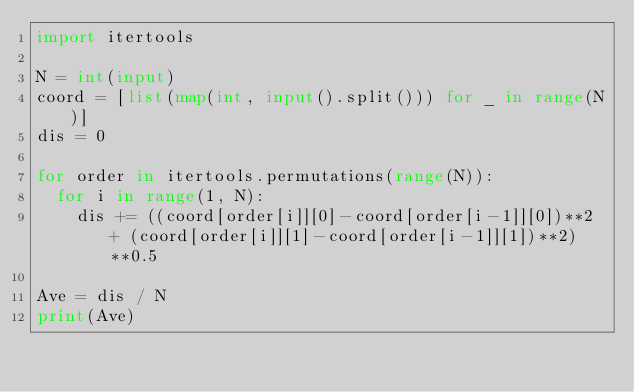Convert code to text. <code><loc_0><loc_0><loc_500><loc_500><_Python_>import itertools
 
N = int(input)
coord = [list(map(int, input().split())) for _ in range(N)]
dis = 0

for order in itertools.permutations(range(N)):
  for i in range(1, N):
    dis += ((coord[order[i]][0]-coord[order[i-1]][0])**2 + (coord[order[i]][1]-coord[order[i-1]][1])**2)**0.5
 
Ave = dis / N
print(Ave)</code> 